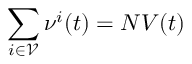<formula> <loc_0><loc_0><loc_500><loc_500>\sum _ { i \in \mathcal { V } } \nu ^ { i } ( t ) = N V ( t )</formula> 